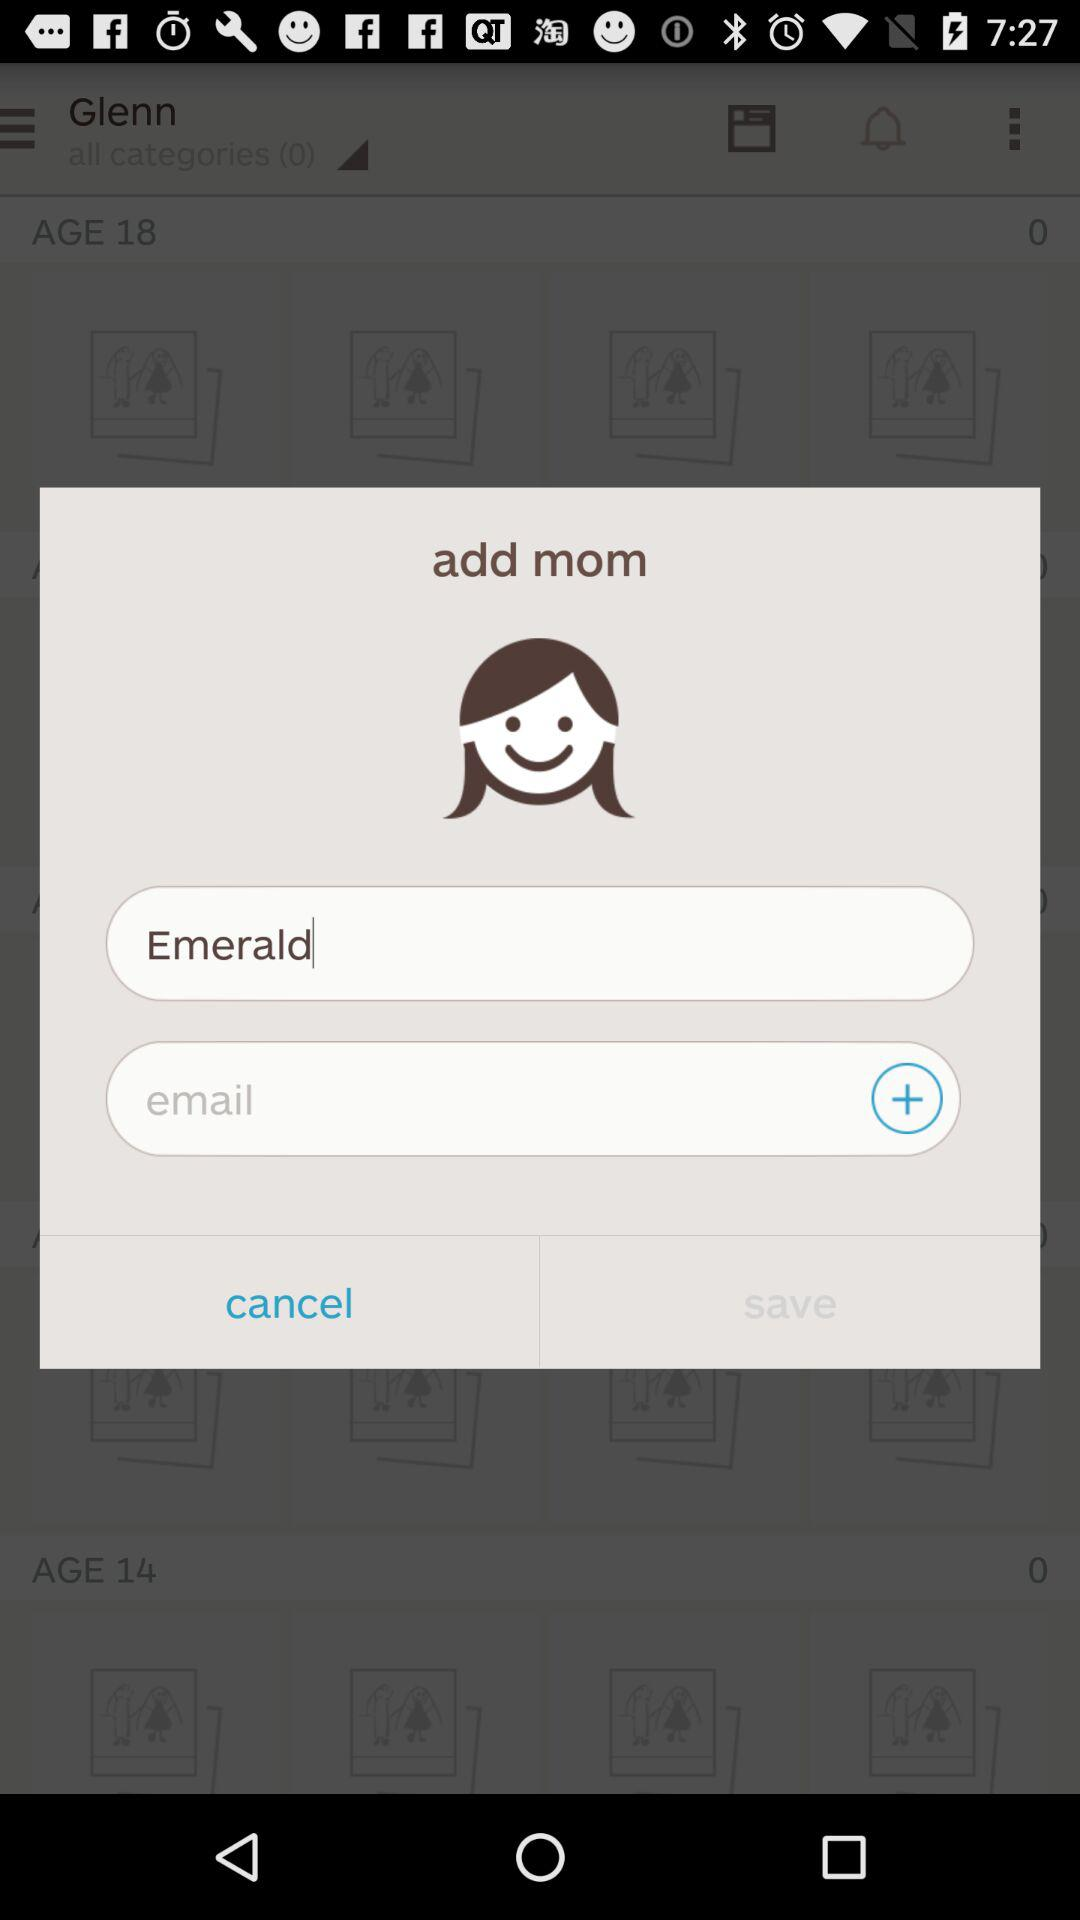What is the entered text? The entered term is Emerald. 